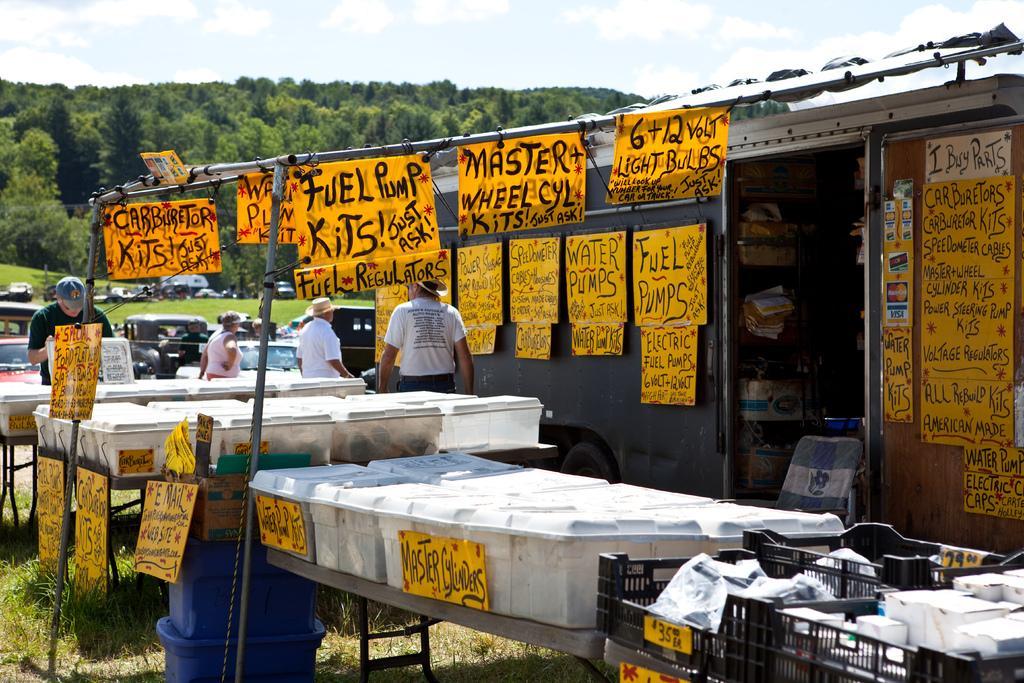In one or two sentences, can you explain what this image depicts? In this picture I can see some people were standing near to the yellow posters. This posters are placed on the pipe and wall. In the bottom I can see many white boxes on the table. In the background I can see trees, plants and grass on the mountain. At the top I can see the sky and clouds. On the left background I can see many vehicles. 